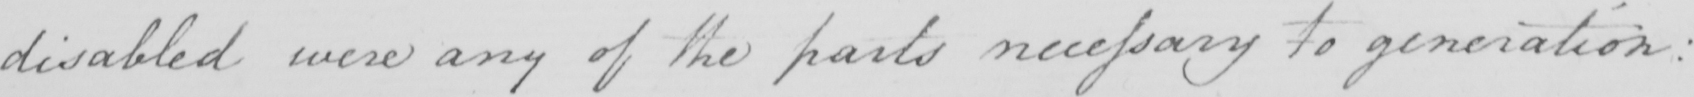Can you tell me what this handwritten text says? disabled were any of the parts necessary to generation : 